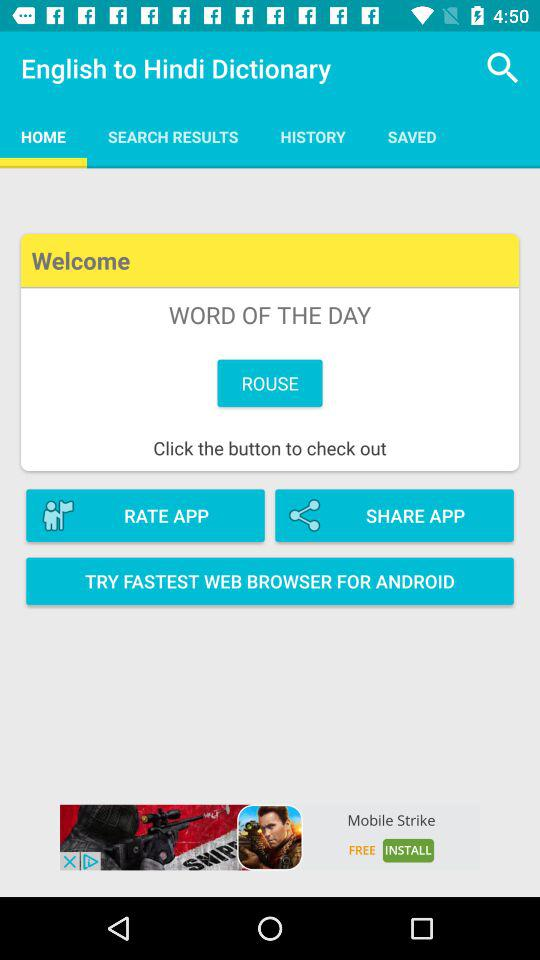Which tab is selected? The selected tab is "HOME". 